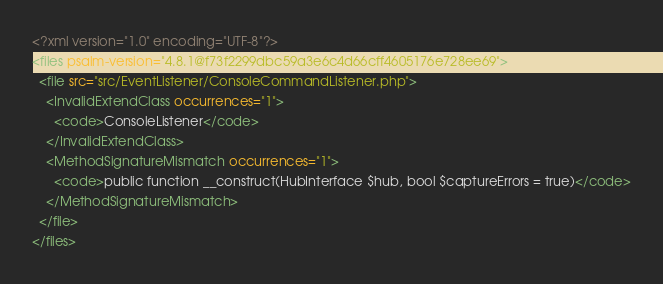Convert code to text. <code><loc_0><loc_0><loc_500><loc_500><_XML_><?xml version="1.0" encoding="UTF-8"?>
<files psalm-version="4.8.1@f73f2299dbc59a3e6c4d66cff4605176e728ee69">
  <file src="src/EventListener/ConsoleCommandListener.php">
    <InvalidExtendClass occurrences="1">
      <code>ConsoleListener</code>
    </InvalidExtendClass>
    <MethodSignatureMismatch occurrences="1">
      <code>public function __construct(HubInterface $hub, bool $captureErrors = true)</code>
    </MethodSignatureMismatch>
  </file>
</files>
</code> 